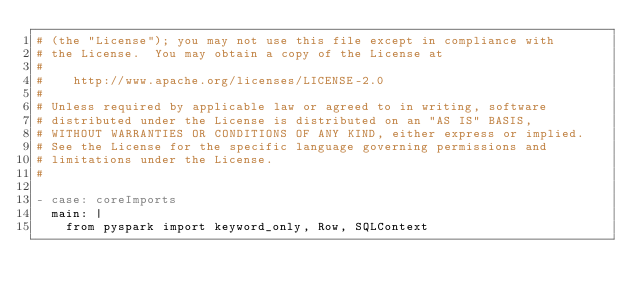<code> <loc_0><loc_0><loc_500><loc_500><_YAML_># (the "License"); you may not use this file except in compliance with
# the License.  You may obtain a copy of the License at
#
#    http://www.apache.org/licenses/LICENSE-2.0
#
# Unless required by applicable law or agreed to in writing, software
# distributed under the License is distributed on an "AS IS" BASIS,
# WITHOUT WARRANTIES OR CONDITIONS OF ANY KIND, either express or implied.
# See the License for the specific language governing permissions and
# limitations under the License.
#

- case: coreImports
  main: |
    from pyspark import keyword_only, Row, SQLContext
</code> 